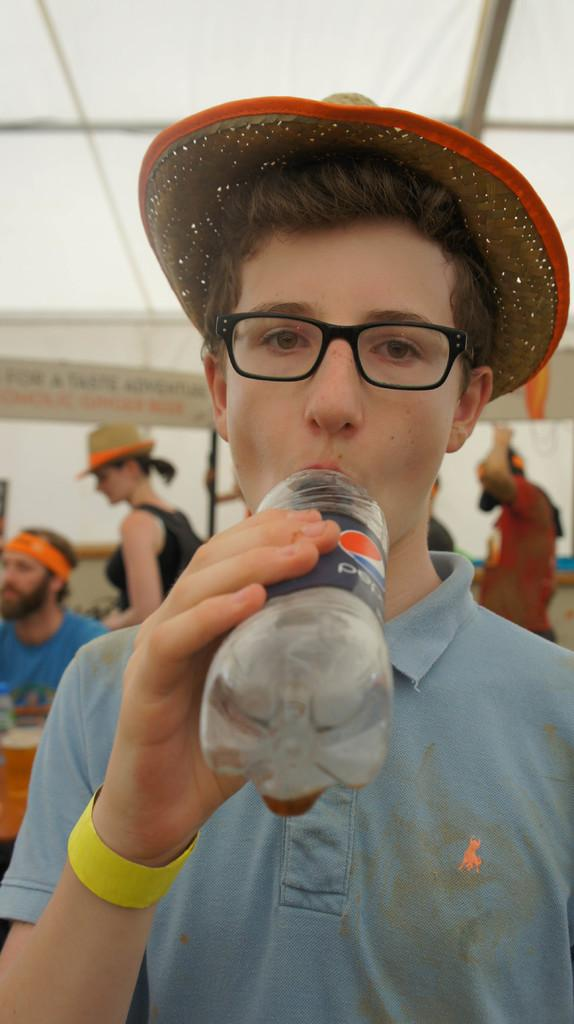Who is the main subject in the image? There is a man in the image. What is the man doing in the image? The man is holding a Pepsi bottle in his mouth. Are there any other people visible in the image? Yes, there are many people behind the man. What is the man wearing on his head? The man is wearing a cap. What type of instrument is the man playing in the image? There is no instrument present in the image; the man is holding a Pepsi bottle in his mouth. How many pies can be seen on the table in the image? There is no table or pies present in the image. 